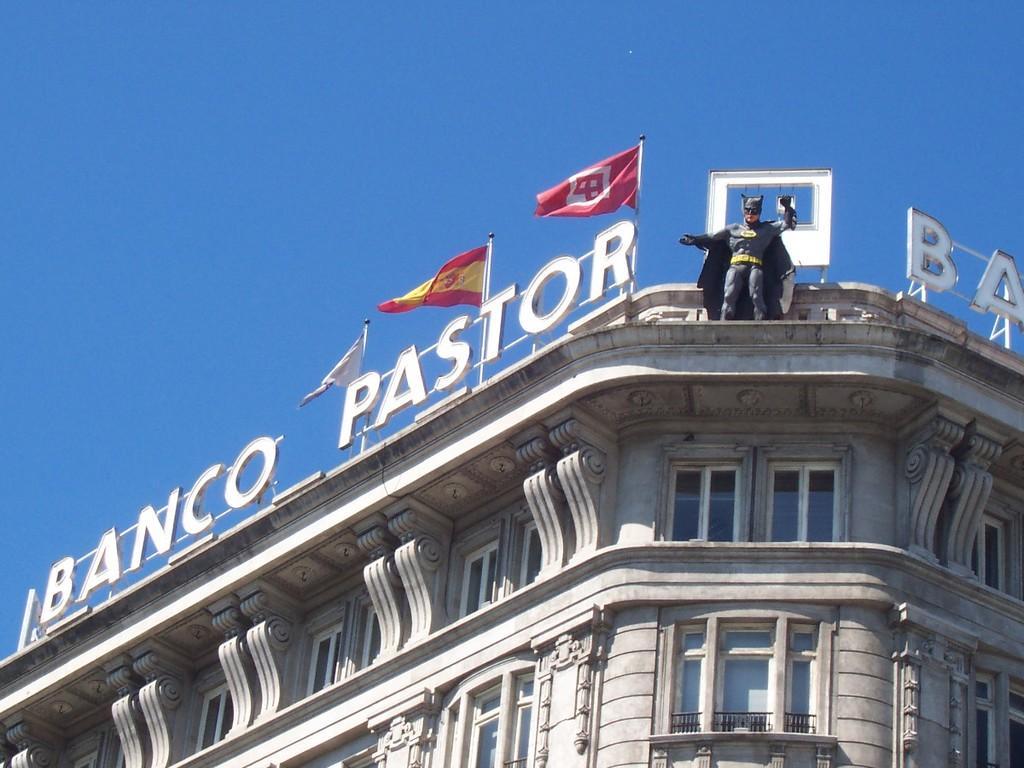Can you describe this image briefly? In this picture we can see few flags and a statue on the building. 